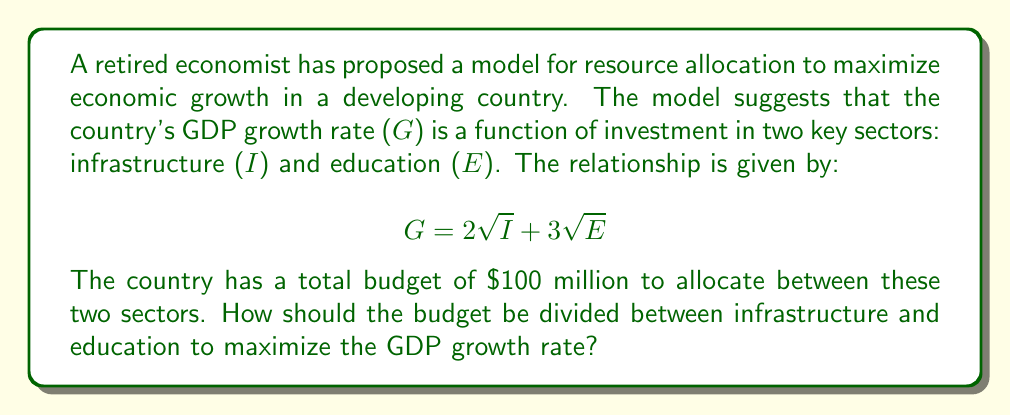What is the answer to this math problem? To solve this optimization problem, we can use the method of Lagrange multipliers. Let's approach this step-by-step:

1) First, we need to set up our constraint equation. The total budget is $100 million, so:

   $$ I + E = 100 $$

2) Our objective function is:

   $$ G = 2\sqrt{I} + 3\sqrt{E} $$

3) We form the Lagrangian function:

   $$ L(I, E, \lambda) = 2\sqrt{I} + 3\sqrt{E} + \lambda(100 - I - E) $$

4) Now, we take partial derivatives and set them to zero:

   $$ \frac{\partial L}{\partial I} = \frac{1}{\sqrt{I}} - \lambda = 0 $$
   $$ \frac{\partial L}{\partial E} = \frac{3}{2\sqrt{E}} - \lambda = 0 $$
   $$ \frac{\partial L}{\partial \lambda} = 100 - I - E = 0 $$

5) From the first two equations:

   $$ \frac{1}{\sqrt{I}} = \lambda $$
   $$ \frac{3}{2\sqrt{E}} = \lambda $$

6) Equating these:

   $$ \frac{1}{\sqrt{I}} = \frac{3}{2\sqrt{E}} $$

7) Squaring both sides:

   $$ \frac{1}{I} = \frac{9}{4E} $$

8) Cross-multiplying:

   $$ 4E = 9I $$

9) Substituting this into our constraint equation:

   $$ I + \frac{4E}{9} = 100 $$
   $$ 9I + 4E = 900 $$

10) Solving this system of equations:

    $$ E = \frac{900 - 9I}{4} $$
    $$ I = 60 $$
    $$ E = 40 $$

Therefore, to maximize GDP growth, the country should invest $60 million in infrastructure and $40 million in education.
Answer: The optimal allocation is $60 million for infrastructure and $40 million for education. 